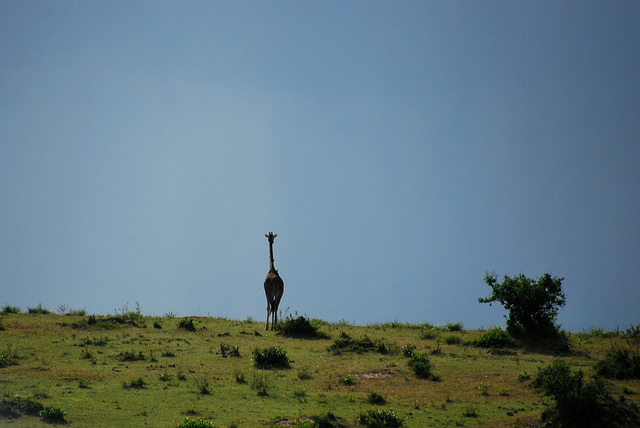<image>Where was the picture taken of the giraffes? I don't know exactly where the picture of the giraffes was taken. It could be in a field or in Africa. Where was the picture taken of the giraffes? I am not sure where the picture was taken of the giraffes. It can be Africa or in nature. 